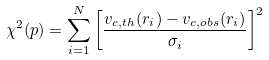Convert formula to latex. <formula><loc_0><loc_0><loc_500><loc_500>\chi ^ { 2 } ( { p } ) = \sum _ { i = 1 } ^ { N } { \left [ \frac { v _ { c , t h } ( r _ { i } ) - v _ { c , o b s } ( r _ { i } ) } { \sigma _ { i } } \right ] ^ { 2 } }</formula> 